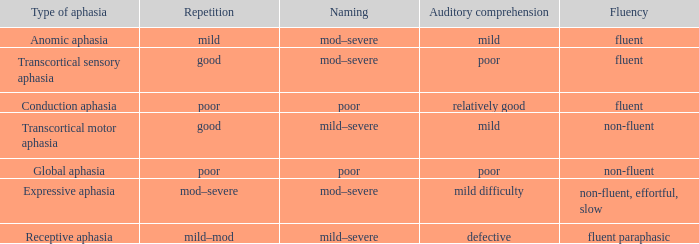Name the naming for fluent and poor comprehension Mod–severe. 